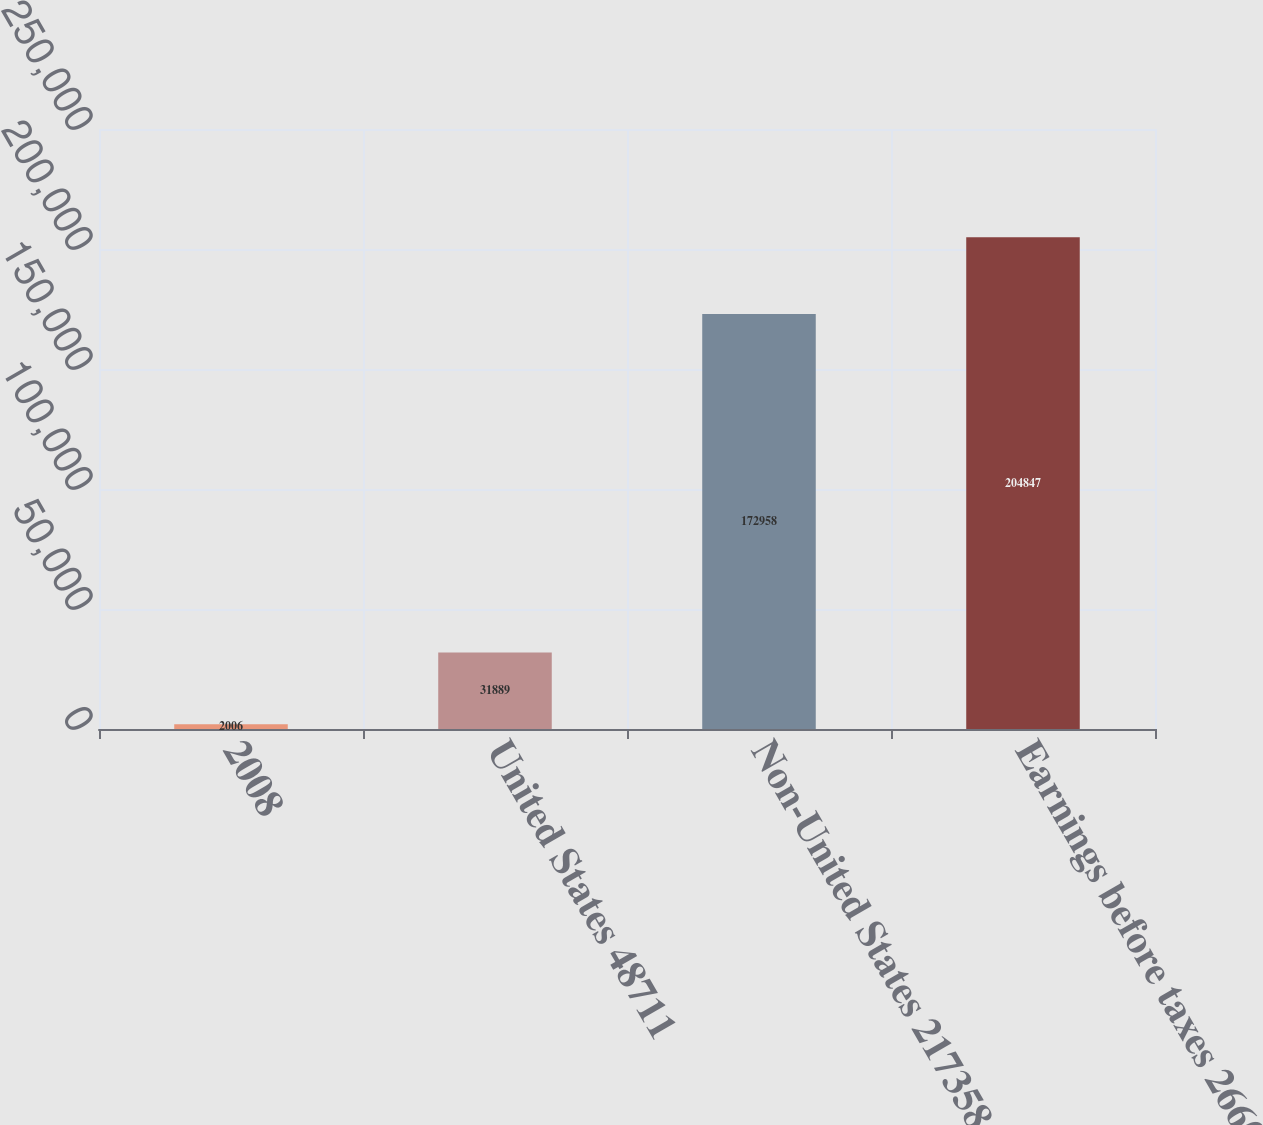<chart> <loc_0><loc_0><loc_500><loc_500><bar_chart><fcel>2008<fcel>United States 48711<fcel>Non-United States 217358<fcel>Earnings before taxes 266069<nl><fcel>2006<fcel>31889<fcel>172958<fcel>204847<nl></chart> 